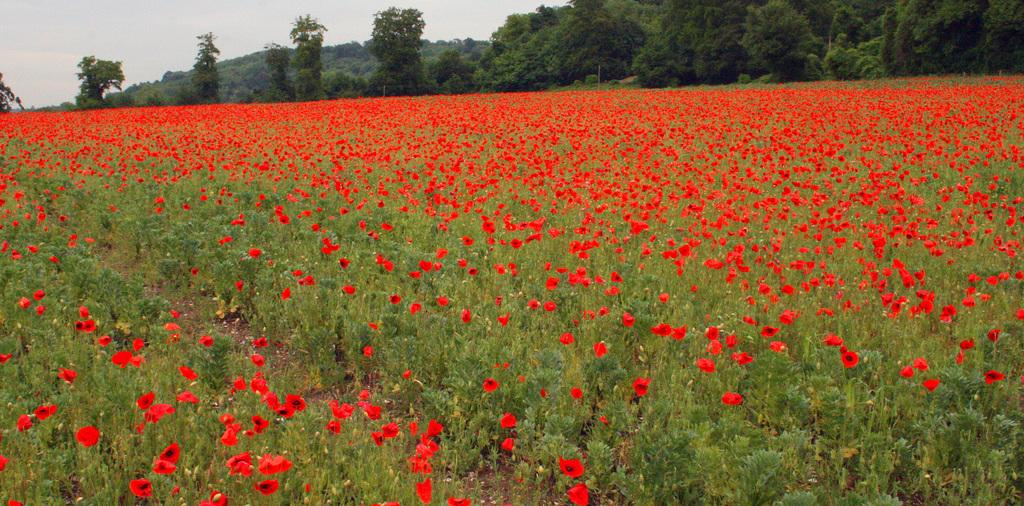What type of vegetation can be seen in the image? There are flowers on the plants and trees visible in the image. Can you describe the plants in the image? The plants in the image have flowers on them. What else can be seen in the image besides the plants? There are trees visible in the image. What song is being sung by the grandfather in the image? There is no grandfather or song present in the image; it features plants with flowers and trees. 